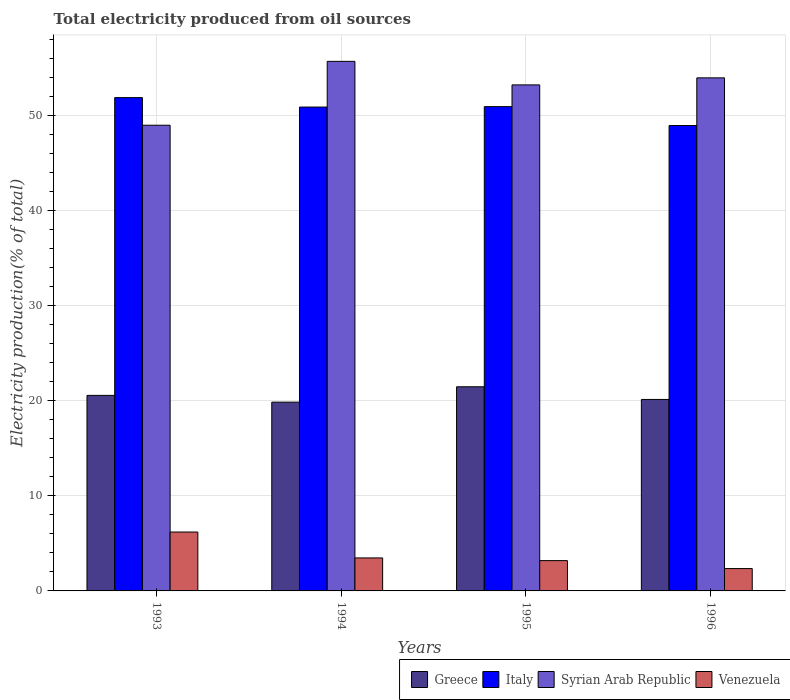How many groups of bars are there?
Keep it short and to the point. 4. Are the number of bars on each tick of the X-axis equal?
Give a very brief answer. Yes. How many bars are there on the 2nd tick from the left?
Make the answer very short. 4. How many bars are there on the 1st tick from the right?
Give a very brief answer. 4. What is the total electricity produced in Greece in 1994?
Your answer should be compact. 19.84. Across all years, what is the maximum total electricity produced in Syrian Arab Republic?
Provide a short and direct response. 55.65. Across all years, what is the minimum total electricity produced in Italy?
Make the answer very short. 48.91. In which year was the total electricity produced in Syrian Arab Republic maximum?
Your answer should be compact. 1994. What is the total total electricity produced in Syrian Arab Republic in the graph?
Your answer should be very brief. 211.69. What is the difference between the total electricity produced in Greece in 1995 and that in 1996?
Your answer should be very brief. 1.33. What is the difference between the total electricity produced in Greece in 1996 and the total electricity produced in Syrian Arab Republic in 1994?
Provide a succinct answer. -35.53. What is the average total electricity produced in Venezuela per year?
Your response must be concise. 3.8. In the year 1993, what is the difference between the total electricity produced in Greece and total electricity produced in Venezuela?
Your answer should be compact. 14.36. In how many years, is the total electricity produced in Syrian Arab Republic greater than 34 %?
Offer a very short reply. 4. What is the ratio of the total electricity produced in Venezuela in 1995 to that in 1996?
Your response must be concise. 1.36. Is the total electricity produced in Italy in 1993 less than that in 1995?
Ensure brevity in your answer.  No. Is the difference between the total electricity produced in Greece in 1994 and 1996 greater than the difference between the total electricity produced in Venezuela in 1994 and 1996?
Your answer should be compact. No. What is the difference between the highest and the second highest total electricity produced in Greece?
Keep it short and to the point. 0.9. What is the difference between the highest and the lowest total electricity produced in Venezuela?
Your response must be concise. 3.84. In how many years, is the total electricity produced in Greece greater than the average total electricity produced in Greece taken over all years?
Ensure brevity in your answer.  2. Is the sum of the total electricity produced in Greece in 1993 and 1995 greater than the maximum total electricity produced in Italy across all years?
Ensure brevity in your answer.  No. Is it the case that in every year, the sum of the total electricity produced in Italy and total electricity produced in Greece is greater than the sum of total electricity produced in Venezuela and total electricity produced in Syrian Arab Republic?
Provide a short and direct response. Yes. What does the 1st bar from the left in 1995 represents?
Your answer should be very brief. Greece. What does the 1st bar from the right in 1993 represents?
Your response must be concise. Venezuela. Is it the case that in every year, the sum of the total electricity produced in Syrian Arab Republic and total electricity produced in Italy is greater than the total electricity produced in Greece?
Your answer should be very brief. Yes. How many years are there in the graph?
Provide a succinct answer. 4. What is the difference between two consecutive major ticks on the Y-axis?
Provide a succinct answer. 10. Are the values on the major ticks of Y-axis written in scientific E-notation?
Provide a short and direct response. No. Where does the legend appear in the graph?
Your answer should be very brief. Bottom right. What is the title of the graph?
Your answer should be very brief. Total electricity produced from oil sources. What is the label or title of the Y-axis?
Your response must be concise. Electricity production(% of total). What is the Electricity production(% of total) of Greece in 1993?
Keep it short and to the point. 20.55. What is the Electricity production(% of total) of Italy in 1993?
Your response must be concise. 51.84. What is the Electricity production(% of total) in Syrian Arab Republic in 1993?
Your answer should be very brief. 48.94. What is the Electricity production(% of total) in Venezuela in 1993?
Offer a very short reply. 6.19. What is the Electricity production(% of total) in Greece in 1994?
Your answer should be very brief. 19.84. What is the Electricity production(% of total) of Italy in 1994?
Your response must be concise. 50.85. What is the Electricity production(% of total) of Syrian Arab Republic in 1994?
Your response must be concise. 55.65. What is the Electricity production(% of total) of Venezuela in 1994?
Give a very brief answer. 3.47. What is the Electricity production(% of total) of Greece in 1995?
Provide a short and direct response. 21.45. What is the Electricity production(% of total) in Italy in 1995?
Give a very brief answer. 50.89. What is the Electricity production(% of total) of Syrian Arab Republic in 1995?
Your response must be concise. 53.18. What is the Electricity production(% of total) in Venezuela in 1995?
Your response must be concise. 3.18. What is the Electricity production(% of total) in Greece in 1996?
Your answer should be very brief. 20.12. What is the Electricity production(% of total) in Italy in 1996?
Your answer should be compact. 48.91. What is the Electricity production(% of total) of Syrian Arab Republic in 1996?
Ensure brevity in your answer.  53.92. What is the Electricity production(% of total) in Venezuela in 1996?
Keep it short and to the point. 2.35. Across all years, what is the maximum Electricity production(% of total) in Greece?
Your response must be concise. 21.45. Across all years, what is the maximum Electricity production(% of total) in Italy?
Your answer should be very brief. 51.84. Across all years, what is the maximum Electricity production(% of total) of Syrian Arab Republic?
Provide a short and direct response. 55.65. Across all years, what is the maximum Electricity production(% of total) of Venezuela?
Make the answer very short. 6.19. Across all years, what is the minimum Electricity production(% of total) in Greece?
Give a very brief answer. 19.84. Across all years, what is the minimum Electricity production(% of total) in Italy?
Ensure brevity in your answer.  48.91. Across all years, what is the minimum Electricity production(% of total) in Syrian Arab Republic?
Your answer should be compact. 48.94. Across all years, what is the minimum Electricity production(% of total) of Venezuela?
Your answer should be compact. 2.35. What is the total Electricity production(% of total) in Greece in the graph?
Provide a succinct answer. 81.96. What is the total Electricity production(% of total) of Italy in the graph?
Give a very brief answer. 202.49. What is the total Electricity production(% of total) of Syrian Arab Republic in the graph?
Your answer should be compact. 211.69. What is the total Electricity production(% of total) of Venezuela in the graph?
Your answer should be compact. 15.19. What is the difference between the Electricity production(% of total) in Greece in 1993 and that in 1994?
Offer a terse response. 0.71. What is the difference between the Electricity production(% of total) of Syrian Arab Republic in 1993 and that in 1994?
Your answer should be very brief. -6.71. What is the difference between the Electricity production(% of total) in Venezuela in 1993 and that in 1994?
Offer a very short reply. 2.72. What is the difference between the Electricity production(% of total) in Greece in 1993 and that in 1995?
Your answer should be compact. -0.9. What is the difference between the Electricity production(% of total) in Italy in 1993 and that in 1995?
Offer a terse response. 0.95. What is the difference between the Electricity production(% of total) in Syrian Arab Republic in 1993 and that in 1995?
Give a very brief answer. -4.24. What is the difference between the Electricity production(% of total) in Venezuela in 1993 and that in 1995?
Offer a very short reply. 3. What is the difference between the Electricity production(% of total) of Greece in 1993 and that in 1996?
Your answer should be compact. 0.43. What is the difference between the Electricity production(% of total) of Italy in 1993 and that in 1996?
Give a very brief answer. 2.93. What is the difference between the Electricity production(% of total) of Syrian Arab Republic in 1993 and that in 1996?
Your answer should be very brief. -4.98. What is the difference between the Electricity production(% of total) of Venezuela in 1993 and that in 1996?
Your answer should be very brief. 3.84. What is the difference between the Electricity production(% of total) of Greece in 1994 and that in 1995?
Ensure brevity in your answer.  -1.61. What is the difference between the Electricity production(% of total) of Italy in 1994 and that in 1995?
Your answer should be very brief. -0.04. What is the difference between the Electricity production(% of total) in Syrian Arab Republic in 1994 and that in 1995?
Give a very brief answer. 2.47. What is the difference between the Electricity production(% of total) in Venezuela in 1994 and that in 1995?
Provide a short and direct response. 0.28. What is the difference between the Electricity production(% of total) of Greece in 1994 and that in 1996?
Offer a very short reply. -0.28. What is the difference between the Electricity production(% of total) in Italy in 1994 and that in 1996?
Provide a short and direct response. 1.94. What is the difference between the Electricity production(% of total) in Syrian Arab Republic in 1994 and that in 1996?
Offer a terse response. 1.73. What is the difference between the Electricity production(% of total) in Venezuela in 1994 and that in 1996?
Offer a very short reply. 1.12. What is the difference between the Electricity production(% of total) of Greece in 1995 and that in 1996?
Keep it short and to the point. 1.33. What is the difference between the Electricity production(% of total) of Italy in 1995 and that in 1996?
Provide a succinct answer. 1.98. What is the difference between the Electricity production(% of total) in Syrian Arab Republic in 1995 and that in 1996?
Provide a short and direct response. -0.74. What is the difference between the Electricity production(% of total) of Venezuela in 1995 and that in 1996?
Ensure brevity in your answer.  0.84. What is the difference between the Electricity production(% of total) of Greece in 1993 and the Electricity production(% of total) of Italy in 1994?
Make the answer very short. -30.3. What is the difference between the Electricity production(% of total) of Greece in 1993 and the Electricity production(% of total) of Syrian Arab Republic in 1994?
Keep it short and to the point. -35.1. What is the difference between the Electricity production(% of total) of Greece in 1993 and the Electricity production(% of total) of Venezuela in 1994?
Give a very brief answer. 17.08. What is the difference between the Electricity production(% of total) in Italy in 1993 and the Electricity production(% of total) in Syrian Arab Republic in 1994?
Ensure brevity in your answer.  -3.81. What is the difference between the Electricity production(% of total) of Italy in 1993 and the Electricity production(% of total) of Venezuela in 1994?
Give a very brief answer. 48.37. What is the difference between the Electricity production(% of total) in Syrian Arab Republic in 1993 and the Electricity production(% of total) in Venezuela in 1994?
Make the answer very short. 45.47. What is the difference between the Electricity production(% of total) of Greece in 1993 and the Electricity production(% of total) of Italy in 1995?
Ensure brevity in your answer.  -30.34. What is the difference between the Electricity production(% of total) in Greece in 1993 and the Electricity production(% of total) in Syrian Arab Republic in 1995?
Your answer should be compact. -32.63. What is the difference between the Electricity production(% of total) in Greece in 1993 and the Electricity production(% of total) in Venezuela in 1995?
Your answer should be compact. 17.36. What is the difference between the Electricity production(% of total) of Italy in 1993 and the Electricity production(% of total) of Syrian Arab Republic in 1995?
Give a very brief answer. -1.34. What is the difference between the Electricity production(% of total) in Italy in 1993 and the Electricity production(% of total) in Venezuela in 1995?
Provide a succinct answer. 48.66. What is the difference between the Electricity production(% of total) in Syrian Arab Republic in 1993 and the Electricity production(% of total) in Venezuela in 1995?
Your answer should be very brief. 45.76. What is the difference between the Electricity production(% of total) of Greece in 1993 and the Electricity production(% of total) of Italy in 1996?
Your answer should be compact. -28.36. What is the difference between the Electricity production(% of total) in Greece in 1993 and the Electricity production(% of total) in Syrian Arab Republic in 1996?
Keep it short and to the point. -33.37. What is the difference between the Electricity production(% of total) in Greece in 1993 and the Electricity production(% of total) in Venezuela in 1996?
Offer a terse response. 18.2. What is the difference between the Electricity production(% of total) in Italy in 1993 and the Electricity production(% of total) in Syrian Arab Republic in 1996?
Provide a short and direct response. -2.08. What is the difference between the Electricity production(% of total) in Italy in 1993 and the Electricity production(% of total) in Venezuela in 1996?
Provide a succinct answer. 49.49. What is the difference between the Electricity production(% of total) of Syrian Arab Republic in 1993 and the Electricity production(% of total) of Venezuela in 1996?
Offer a very short reply. 46.59. What is the difference between the Electricity production(% of total) in Greece in 1994 and the Electricity production(% of total) in Italy in 1995?
Your response must be concise. -31.05. What is the difference between the Electricity production(% of total) of Greece in 1994 and the Electricity production(% of total) of Syrian Arab Republic in 1995?
Your answer should be compact. -33.34. What is the difference between the Electricity production(% of total) of Greece in 1994 and the Electricity production(% of total) of Venezuela in 1995?
Offer a terse response. 16.65. What is the difference between the Electricity production(% of total) in Italy in 1994 and the Electricity production(% of total) in Syrian Arab Republic in 1995?
Ensure brevity in your answer.  -2.33. What is the difference between the Electricity production(% of total) of Italy in 1994 and the Electricity production(% of total) of Venezuela in 1995?
Your answer should be very brief. 47.66. What is the difference between the Electricity production(% of total) of Syrian Arab Republic in 1994 and the Electricity production(% of total) of Venezuela in 1995?
Provide a short and direct response. 52.47. What is the difference between the Electricity production(% of total) in Greece in 1994 and the Electricity production(% of total) in Italy in 1996?
Offer a terse response. -29.07. What is the difference between the Electricity production(% of total) of Greece in 1994 and the Electricity production(% of total) of Syrian Arab Republic in 1996?
Your response must be concise. -34.08. What is the difference between the Electricity production(% of total) in Greece in 1994 and the Electricity production(% of total) in Venezuela in 1996?
Provide a short and direct response. 17.49. What is the difference between the Electricity production(% of total) in Italy in 1994 and the Electricity production(% of total) in Syrian Arab Republic in 1996?
Your answer should be very brief. -3.07. What is the difference between the Electricity production(% of total) in Italy in 1994 and the Electricity production(% of total) in Venezuela in 1996?
Your answer should be compact. 48.5. What is the difference between the Electricity production(% of total) in Syrian Arab Republic in 1994 and the Electricity production(% of total) in Venezuela in 1996?
Your answer should be compact. 53.3. What is the difference between the Electricity production(% of total) in Greece in 1995 and the Electricity production(% of total) in Italy in 1996?
Give a very brief answer. -27.46. What is the difference between the Electricity production(% of total) in Greece in 1995 and the Electricity production(% of total) in Syrian Arab Republic in 1996?
Offer a very short reply. -32.46. What is the difference between the Electricity production(% of total) in Greece in 1995 and the Electricity production(% of total) in Venezuela in 1996?
Your answer should be compact. 19.11. What is the difference between the Electricity production(% of total) in Italy in 1995 and the Electricity production(% of total) in Syrian Arab Republic in 1996?
Provide a short and direct response. -3.03. What is the difference between the Electricity production(% of total) in Italy in 1995 and the Electricity production(% of total) in Venezuela in 1996?
Your answer should be very brief. 48.54. What is the difference between the Electricity production(% of total) of Syrian Arab Republic in 1995 and the Electricity production(% of total) of Venezuela in 1996?
Your response must be concise. 50.83. What is the average Electricity production(% of total) in Greece per year?
Your answer should be very brief. 20.49. What is the average Electricity production(% of total) of Italy per year?
Make the answer very short. 50.62. What is the average Electricity production(% of total) of Syrian Arab Republic per year?
Keep it short and to the point. 52.92. What is the average Electricity production(% of total) in Venezuela per year?
Your response must be concise. 3.8. In the year 1993, what is the difference between the Electricity production(% of total) in Greece and Electricity production(% of total) in Italy?
Your answer should be very brief. -31.29. In the year 1993, what is the difference between the Electricity production(% of total) of Greece and Electricity production(% of total) of Syrian Arab Republic?
Offer a very short reply. -28.39. In the year 1993, what is the difference between the Electricity production(% of total) of Greece and Electricity production(% of total) of Venezuela?
Your response must be concise. 14.36. In the year 1993, what is the difference between the Electricity production(% of total) in Italy and Electricity production(% of total) in Syrian Arab Republic?
Keep it short and to the point. 2.9. In the year 1993, what is the difference between the Electricity production(% of total) in Italy and Electricity production(% of total) in Venezuela?
Give a very brief answer. 45.65. In the year 1993, what is the difference between the Electricity production(% of total) in Syrian Arab Republic and Electricity production(% of total) in Venezuela?
Provide a succinct answer. 42.75. In the year 1994, what is the difference between the Electricity production(% of total) of Greece and Electricity production(% of total) of Italy?
Provide a succinct answer. -31.01. In the year 1994, what is the difference between the Electricity production(% of total) in Greece and Electricity production(% of total) in Syrian Arab Republic?
Your answer should be very brief. -35.81. In the year 1994, what is the difference between the Electricity production(% of total) in Greece and Electricity production(% of total) in Venezuela?
Provide a succinct answer. 16.37. In the year 1994, what is the difference between the Electricity production(% of total) of Italy and Electricity production(% of total) of Syrian Arab Republic?
Offer a terse response. -4.8. In the year 1994, what is the difference between the Electricity production(% of total) of Italy and Electricity production(% of total) of Venezuela?
Offer a very short reply. 47.38. In the year 1994, what is the difference between the Electricity production(% of total) of Syrian Arab Republic and Electricity production(% of total) of Venezuela?
Your answer should be very brief. 52.18. In the year 1995, what is the difference between the Electricity production(% of total) of Greece and Electricity production(% of total) of Italy?
Keep it short and to the point. -29.44. In the year 1995, what is the difference between the Electricity production(% of total) of Greece and Electricity production(% of total) of Syrian Arab Republic?
Your answer should be very brief. -31.72. In the year 1995, what is the difference between the Electricity production(% of total) of Greece and Electricity production(% of total) of Venezuela?
Offer a terse response. 18.27. In the year 1995, what is the difference between the Electricity production(% of total) in Italy and Electricity production(% of total) in Syrian Arab Republic?
Provide a succinct answer. -2.28. In the year 1995, what is the difference between the Electricity production(% of total) of Italy and Electricity production(% of total) of Venezuela?
Offer a very short reply. 47.71. In the year 1995, what is the difference between the Electricity production(% of total) of Syrian Arab Republic and Electricity production(% of total) of Venezuela?
Provide a short and direct response. 49.99. In the year 1996, what is the difference between the Electricity production(% of total) in Greece and Electricity production(% of total) in Italy?
Provide a short and direct response. -28.79. In the year 1996, what is the difference between the Electricity production(% of total) of Greece and Electricity production(% of total) of Syrian Arab Republic?
Offer a very short reply. -33.8. In the year 1996, what is the difference between the Electricity production(% of total) in Greece and Electricity production(% of total) in Venezuela?
Make the answer very short. 17.77. In the year 1996, what is the difference between the Electricity production(% of total) in Italy and Electricity production(% of total) in Syrian Arab Republic?
Ensure brevity in your answer.  -5.01. In the year 1996, what is the difference between the Electricity production(% of total) in Italy and Electricity production(% of total) in Venezuela?
Your answer should be compact. 46.56. In the year 1996, what is the difference between the Electricity production(% of total) of Syrian Arab Republic and Electricity production(% of total) of Venezuela?
Keep it short and to the point. 51.57. What is the ratio of the Electricity production(% of total) of Greece in 1993 to that in 1994?
Your answer should be very brief. 1.04. What is the ratio of the Electricity production(% of total) of Italy in 1993 to that in 1994?
Your answer should be very brief. 1.02. What is the ratio of the Electricity production(% of total) of Syrian Arab Republic in 1993 to that in 1994?
Make the answer very short. 0.88. What is the ratio of the Electricity production(% of total) of Venezuela in 1993 to that in 1994?
Your response must be concise. 1.79. What is the ratio of the Electricity production(% of total) in Greece in 1993 to that in 1995?
Your answer should be compact. 0.96. What is the ratio of the Electricity production(% of total) of Italy in 1993 to that in 1995?
Your response must be concise. 1.02. What is the ratio of the Electricity production(% of total) of Syrian Arab Republic in 1993 to that in 1995?
Ensure brevity in your answer.  0.92. What is the ratio of the Electricity production(% of total) in Venezuela in 1993 to that in 1995?
Provide a short and direct response. 1.94. What is the ratio of the Electricity production(% of total) of Greece in 1993 to that in 1996?
Ensure brevity in your answer.  1.02. What is the ratio of the Electricity production(% of total) of Italy in 1993 to that in 1996?
Your response must be concise. 1.06. What is the ratio of the Electricity production(% of total) in Syrian Arab Republic in 1993 to that in 1996?
Give a very brief answer. 0.91. What is the ratio of the Electricity production(% of total) in Venezuela in 1993 to that in 1996?
Offer a terse response. 2.64. What is the ratio of the Electricity production(% of total) of Greece in 1994 to that in 1995?
Provide a short and direct response. 0.92. What is the ratio of the Electricity production(% of total) of Syrian Arab Republic in 1994 to that in 1995?
Offer a terse response. 1.05. What is the ratio of the Electricity production(% of total) in Venezuela in 1994 to that in 1995?
Offer a very short reply. 1.09. What is the ratio of the Electricity production(% of total) of Greece in 1994 to that in 1996?
Make the answer very short. 0.99. What is the ratio of the Electricity production(% of total) of Italy in 1994 to that in 1996?
Offer a terse response. 1.04. What is the ratio of the Electricity production(% of total) in Syrian Arab Republic in 1994 to that in 1996?
Your answer should be very brief. 1.03. What is the ratio of the Electricity production(% of total) in Venezuela in 1994 to that in 1996?
Make the answer very short. 1.48. What is the ratio of the Electricity production(% of total) in Greece in 1995 to that in 1996?
Offer a very short reply. 1.07. What is the ratio of the Electricity production(% of total) in Italy in 1995 to that in 1996?
Your answer should be very brief. 1.04. What is the ratio of the Electricity production(% of total) in Syrian Arab Republic in 1995 to that in 1996?
Offer a terse response. 0.99. What is the ratio of the Electricity production(% of total) of Venezuela in 1995 to that in 1996?
Ensure brevity in your answer.  1.36. What is the difference between the highest and the second highest Electricity production(% of total) in Greece?
Your answer should be compact. 0.9. What is the difference between the highest and the second highest Electricity production(% of total) of Italy?
Keep it short and to the point. 0.95. What is the difference between the highest and the second highest Electricity production(% of total) of Syrian Arab Republic?
Your response must be concise. 1.73. What is the difference between the highest and the second highest Electricity production(% of total) in Venezuela?
Give a very brief answer. 2.72. What is the difference between the highest and the lowest Electricity production(% of total) in Greece?
Make the answer very short. 1.61. What is the difference between the highest and the lowest Electricity production(% of total) in Italy?
Keep it short and to the point. 2.93. What is the difference between the highest and the lowest Electricity production(% of total) in Syrian Arab Republic?
Offer a terse response. 6.71. What is the difference between the highest and the lowest Electricity production(% of total) of Venezuela?
Your response must be concise. 3.84. 